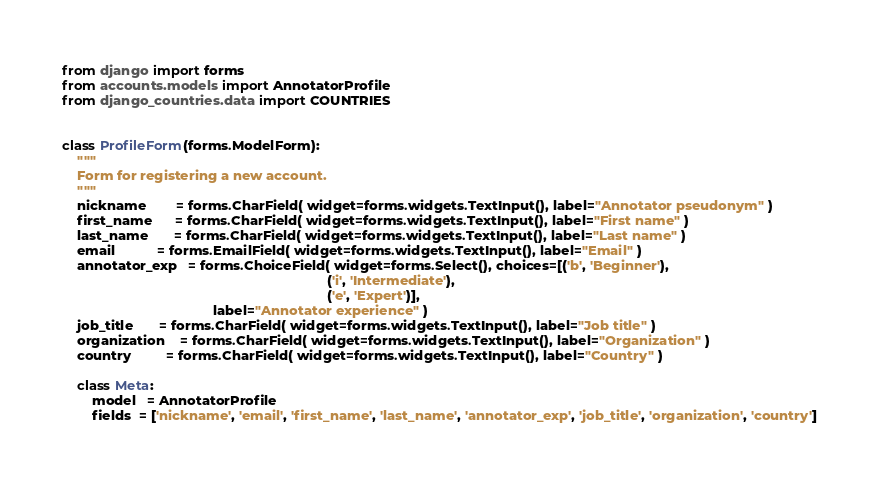Convert code to text. <code><loc_0><loc_0><loc_500><loc_500><_Python_>from django import forms
from accounts.models import AnnotatorProfile
from django_countries.data import COUNTRIES


class ProfileForm(forms.ModelForm):
    """
    Form for registering a new account.
    """
    nickname        = forms.CharField( widget=forms.widgets.TextInput(), label="Annotator pseudonym" )
    first_name      = forms.CharField( widget=forms.widgets.TextInput(), label="First name" )
    last_name       = forms.CharField( widget=forms.widgets.TextInput(), label="Last name" )
    email           = forms.EmailField( widget=forms.widgets.TextInput(), label="Email" )
    annotator_exp   = forms.ChoiceField( widget=forms.Select(), choices=[('b', 'Beginner'),
                                                                      ('i', 'Intermediate'),
                                                                      ('e', 'Expert')],
                                        label="Annotator experience" )
    job_title       = forms.CharField( widget=forms.widgets.TextInput(), label="Job title" )
    organization    = forms.CharField( widget=forms.widgets.TextInput(), label="Organization" )
    country         = forms.CharField( widget=forms.widgets.TextInput(), label="Country" )

    class Meta:
        model   = AnnotatorProfile
        fields  = ['nickname', 'email', 'first_name', 'last_name', 'annotator_exp', 'job_title', 'organization', 'country']
</code> 